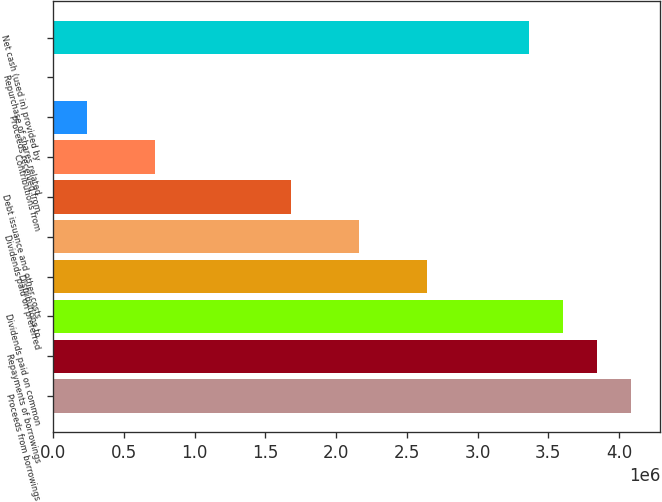Convert chart to OTSL. <chart><loc_0><loc_0><loc_500><loc_500><bar_chart><fcel>Proceeds from borrowings<fcel>Repayments of borrowings<fcel>Dividends paid on common<fcel>Distributions to<fcel>Dividends paid on preferred<fcel>Debt issuance and other costs<fcel>Contributions from<fcel>Proceeds received from<fcel>Repurchase of shares related<fcel>Net cash (used in) provided by<nl><fcel>4.0865e+06<fcel>3.84613e+06<fcel>3.60575e+06<fcel>2.64427e+06<fcel>2.16353e+06<fcel>1.68278e+06<fcel>721300<fcel>240557<fcel>186<fcel>3.36538e+06<nl></chart> 